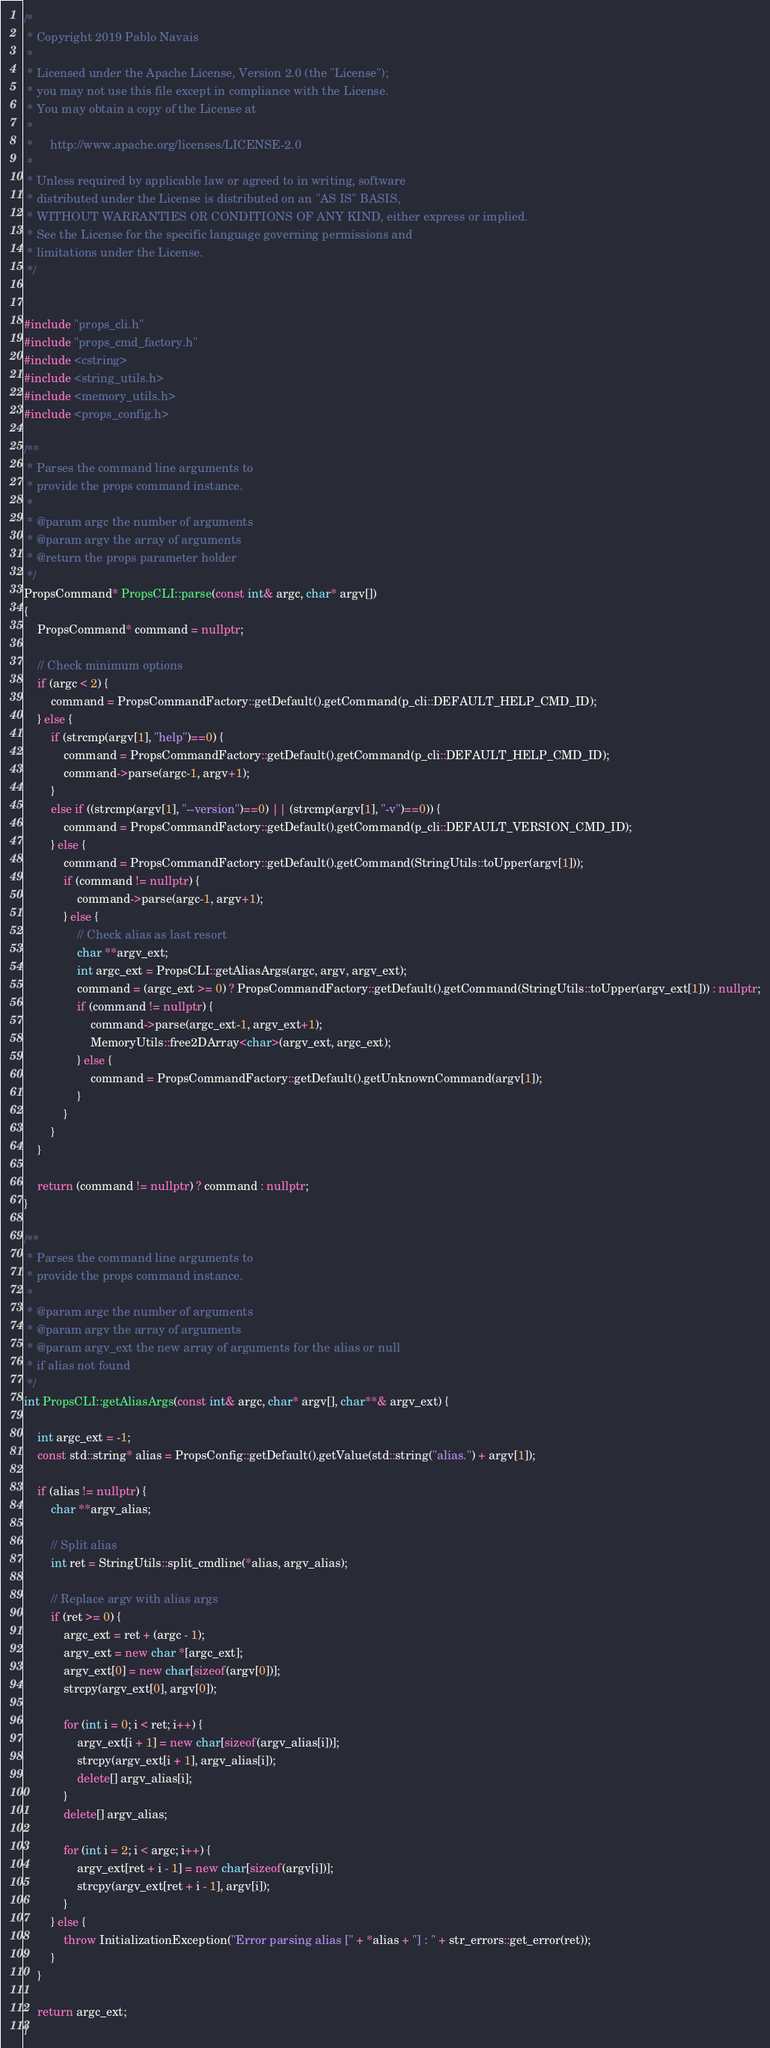Convert code to text. <code><loc_0><loc_0><loc_500><loc_500><_C++_>/*
 * Copyright 2019 Pablo Navais
 *
 * Licensed under the Apache License, Version 2.0 (the "License");
 * you may not use this file except in compliance with the License.
 * You may obtain a copy of the License at
 *
 *     http://www.apache.org/licenses/LICENSE-2.0
 *
 * Unless required by applicable law or agreed to in writing, software
 * distributed under the License is distributed on an "AS IS" BASIS,
 * WITHOUT WARRANTIES OR CONDITIONS OF ANY KIND, either express or implied.
 * See the License for the specific language governing permissions and
 * limitations under the License.
 */


#include "props_cli.h"
#include "props_cmd_factory.h"
#include <cstring>
#include <string_utils.h>
#include <memory_utils.h>
#include <props_config.h>

/**
 * Parses the command line arguments to
 * provide the props command instance.
 *
 * @param argc the number of arguments
 * @param argv the array of arguments
 * @return the props parameter holder
 */
PropsCommand* PropsCLI::parse(const int& argc, char* argv[])
{
    PropsCommand* command = nullptr;

	// Check minimum options
	if (argc < 2) {
        command = PropsCommandFactory::getDefault().getCommand(p_cli::DEFAULT_HELP_CMD_ID);
	} else {
	    if (strcmp(argv[1], "help")==0) {
            command = PropsCommandFactory::getDefault().getCommand(p_cli::DEFAULT_HELP_CMD_ID);
            command->parse(argc-1, argv+1);
	    }
	    else if ((strcmp(argv[1], "--version")==0) || (strcmp(argv[1], "-v")==0)) {
            command = PropsCommandFactory::getDefault().getCommand(p_cli::DEFAULT_VERSION_CMD_ID);
	    } else {
            command = PropsCommandFactory::getDefault().getCommand(StringUtils::toUpper(argv[1]));
            if (command != nullptr) {
                command->parse(argc-1, argv+1);
            } else {
                // Check alias as last resort
                char **argv_ext;
                int argc_ext = PropsCLI::getAliasArgs(argc, argv, argv_ext);
                command = (argc_ext >= 0) ? PropsCommandFactory::getDefault().getCommand(StringUtils::toUpper(argv_ext[1])) : nullptr;
                if (command != nullptr) {
                    command->parse(argc_ext-1, argv_ext+1);
                    MemoryUtils::free2DArray<char>(argv_ext, argc_ext);
                } else {
                    command = PropsCommandFactory::getDefault().getUnknownCommand(argv[1]);
                }
            }
	    }
	}

	return (command != nullptr) ? command : nullptr;
}

/**
 * Parses the command line arguments to
 * provide the props command instance.
 *
 * @param argc the number of arguments
 * @param argv the array of arguments
 * @param argv_ext the new array of arguments for the alias or null
 * if alias not found
 */
int PropsCLI::getAliasArgs(const int& argc, char* argv[], char**& argv_ext) {

    int argc_ext = -1;
    const std::string* alias = PropsConfig::getDefault().getValue(std::string("alias.") + argv[1]);

    if (alias != nullptr) {
        char **argv_alias;

        // Split alias
        int ret = StringUtils::split_cmdline(*alias, argv_alias);

        // Replace argv with alias args
        if (ret >= 0) {
            argc_ext = ret + (argc - 1);
            argv_ext = new char *[argc_ext];
            argv_ext[0] = new char[sizeof(argv[0])];
            strcpy(argv_ext[0], argv[0]);

            for (int i = 0; i < ret; i++) {
                argv_ext[i + 1] = new char[sizeof(argv_alias[i])];
                strcpy(argv_ext[i + 1], argv_alias[i]);
                delete[] argv_alias[i];
            }
            delete[] argv_alias;

            for (int i = 2; i < argc; i++) {
                argv_ext[ret + i - 1] = new char[sizeof(argv[i])];
                strcpy(argv_ext[ret + i - 1], argv[i]);
            }
        } else {
            throw InitializationException("Error parsing alias [" + *alias + "] : " + str_errors::get_error(ret));
        }
    }

    return argc_ext;
}
</code> 